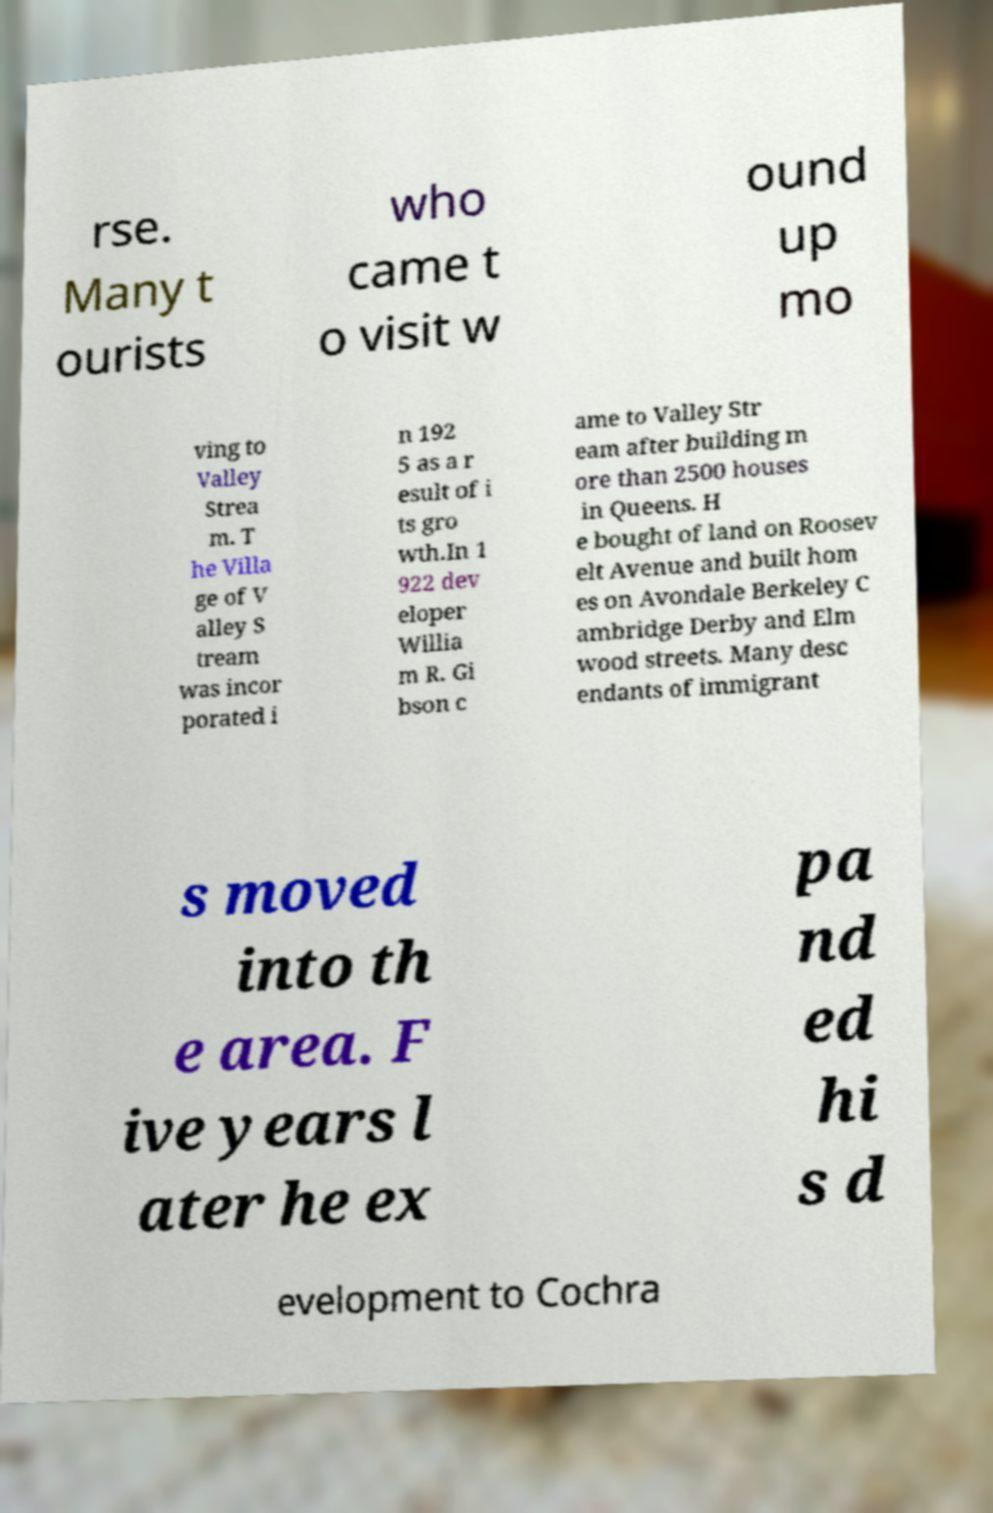Could you assist in decoding the text presented in this image and type it out clearly? rse. Many t ourists who came t o visit w ound up mo ving to Valley Strea m. T he Villa ge of V alley S tream was incor porated i n 192 5 as a r esult of i ts gro wth.In 1 922 dev eloper Willia m R. Gi bson c ame to Valley Str eam after building m ore than 2500 houses in Queens. H e bought of land on Roosev elt Avenue and built hom es on Avondale Berkeley C ambridge Derby and Elm wood streets. Many desc endants of immigrant s moved into th e area. F ive years l ater he ex pa nd ed hi s d evelopment to Cochra 